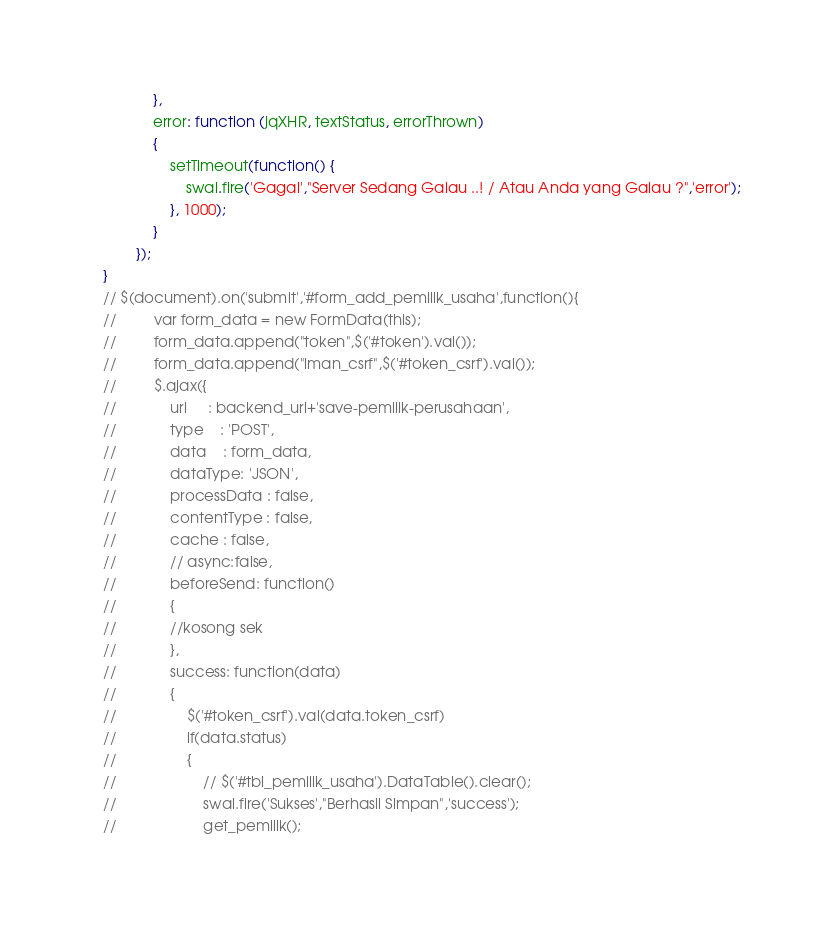Convert code to text. <code><loc_0><loc_0><loc_500><loc_500><_JavaScript_>            },
            error: function (jqXHR, textStatus, errorThrown)
            {
                setTimeout(function() {
                    swal.fire('Gagal',"Server Sedang Galau ..! / Atau Anda yang Galau ?",'error');
                }, 1000);
            }
        });
}
// $(document).on('submit','#form_add_pemilik_usaha',function(){
//         var form_data = new FormData(this);
//         form_data.append("token",$('#token').val());
//         form_data.append("lman_csrf",$('#token_csrf').val());
//         $.ajax({
//             url     : backend_url+'save-pemilik-perusahaan',
//             type    : 'POST',
//             data    : form_data,
//             dataType: 'JSON',
//             processData : false,
//             contentType : false,
//             cache : false,
//             // async:false,
//             beforeSend: function()
//             {
//             //kosong sek
//             },
//             success: function(data)
//             {
//                 $('#token_csrf').val(data.token_csrf)
//                 if(data.status)
//                 {
//                     // $('#tbl_pemilik_usaha').DataTable().clear();
//                     swal.fire('Sukses',"Berhasil Simpan",'success');
//                     get_pemilik();</code> 